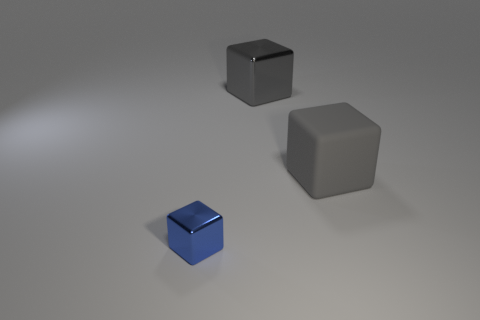Subtract all small blocks. How many blocks are left? 2 Subtract all blue cubes. How many cubes are left? 2 Add 3 big gray metal cubes. How many big gray metal cubes exist? 4 Add 1 gray objects. How many objects exist? 4 Subtract 0 yellow cylinders. How many objects are left? 3 Subtract 2 blocks. How many blocks are left? 1 Subtract all brown blocks. Subtract all gray balls. How many blocks are left? 3 Subtract all purple balls. How many gray cubes are left? 2 Subtract all large rubber objects. Subtract all small objects. How many objects are left? 1 Add 2 metallic blocks. How many metallic blocks are left? 4 